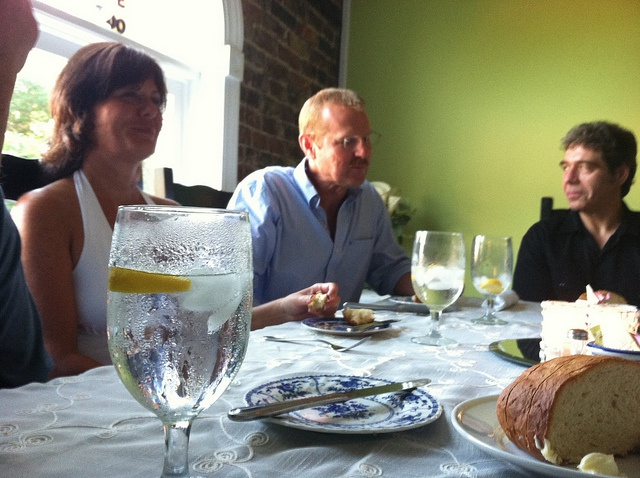Describe the objects in this image and their specific colors. I can see dining table in brown, darkgray, lightgray, gray, and lightblue tones, people in brown, maroon, black, and gray tones, wine glass in brown, darkgray, lightgray, and gray tones, people in brown, gray, black, and ivory tones, and people in brown, black, and maroon tones in this image. 